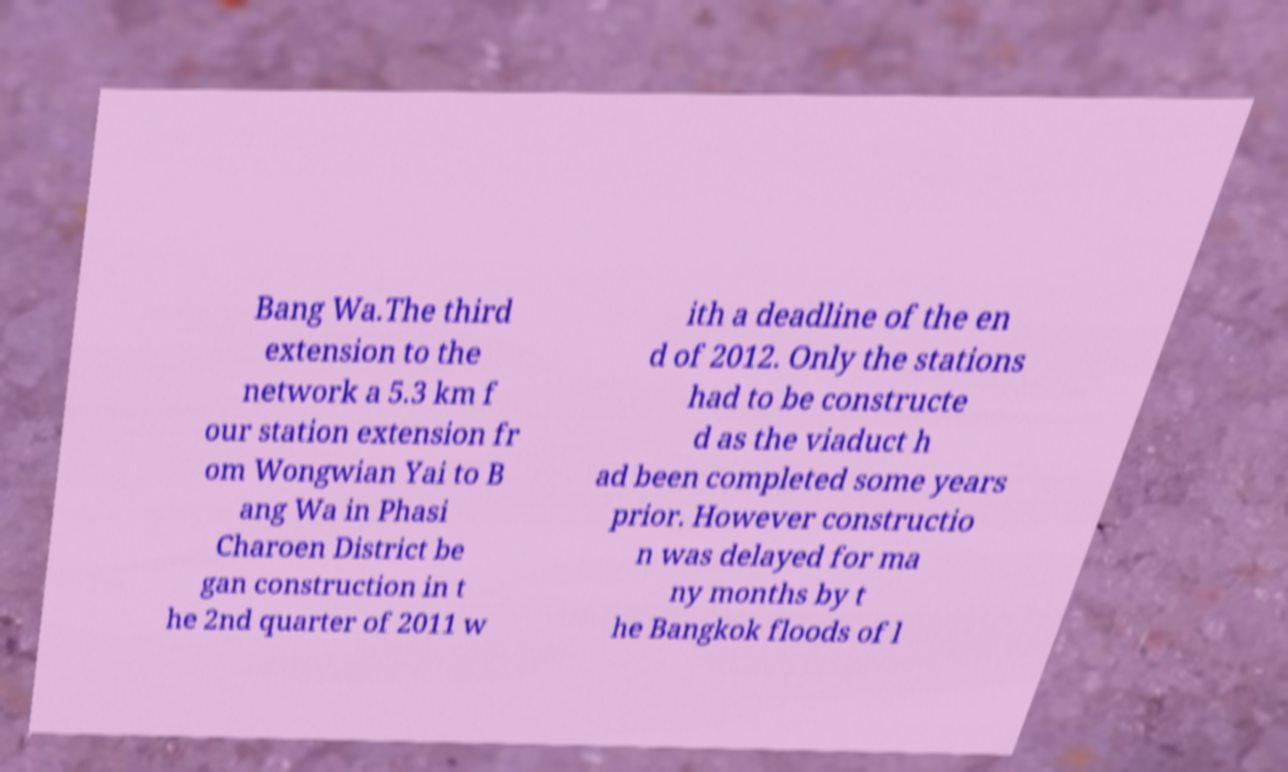I need the written content from this picture converted into text. Can you do that? Bang Wa.The third extension to the network a 5.3 km f our station extension fr om Wongwian Yai to B ang Wa in Phasi Charoen District be gan construction in t he 2nd quarter of 2011 w ith a deadline of the en d of 2012. Only the stations had to be constructe d as the viaduct h ad been completed some years prior. However constructio n was delayed for ma ny months by t he Bangkok floods of l 